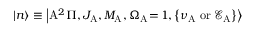Convert formula to latex. <formula><loc_0><loc_0><loc_500><loc_500>\left | n \right > \equiv \left | A ^ { 2 } \Pi , J _ { A } , M _ { A } , \Omega _ { A } \, = \, 1 , \left \{ \nu _ { A } \, o r \, \mathcal { E } _ { A } \right \} \right ></formula> 